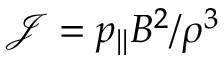<formula> <loc_0><loc_0><loc_500><loc_500>\mathcal { J } = p _ { \| } B ^ { 2 } / \rho ^ { 3 }</formula> 